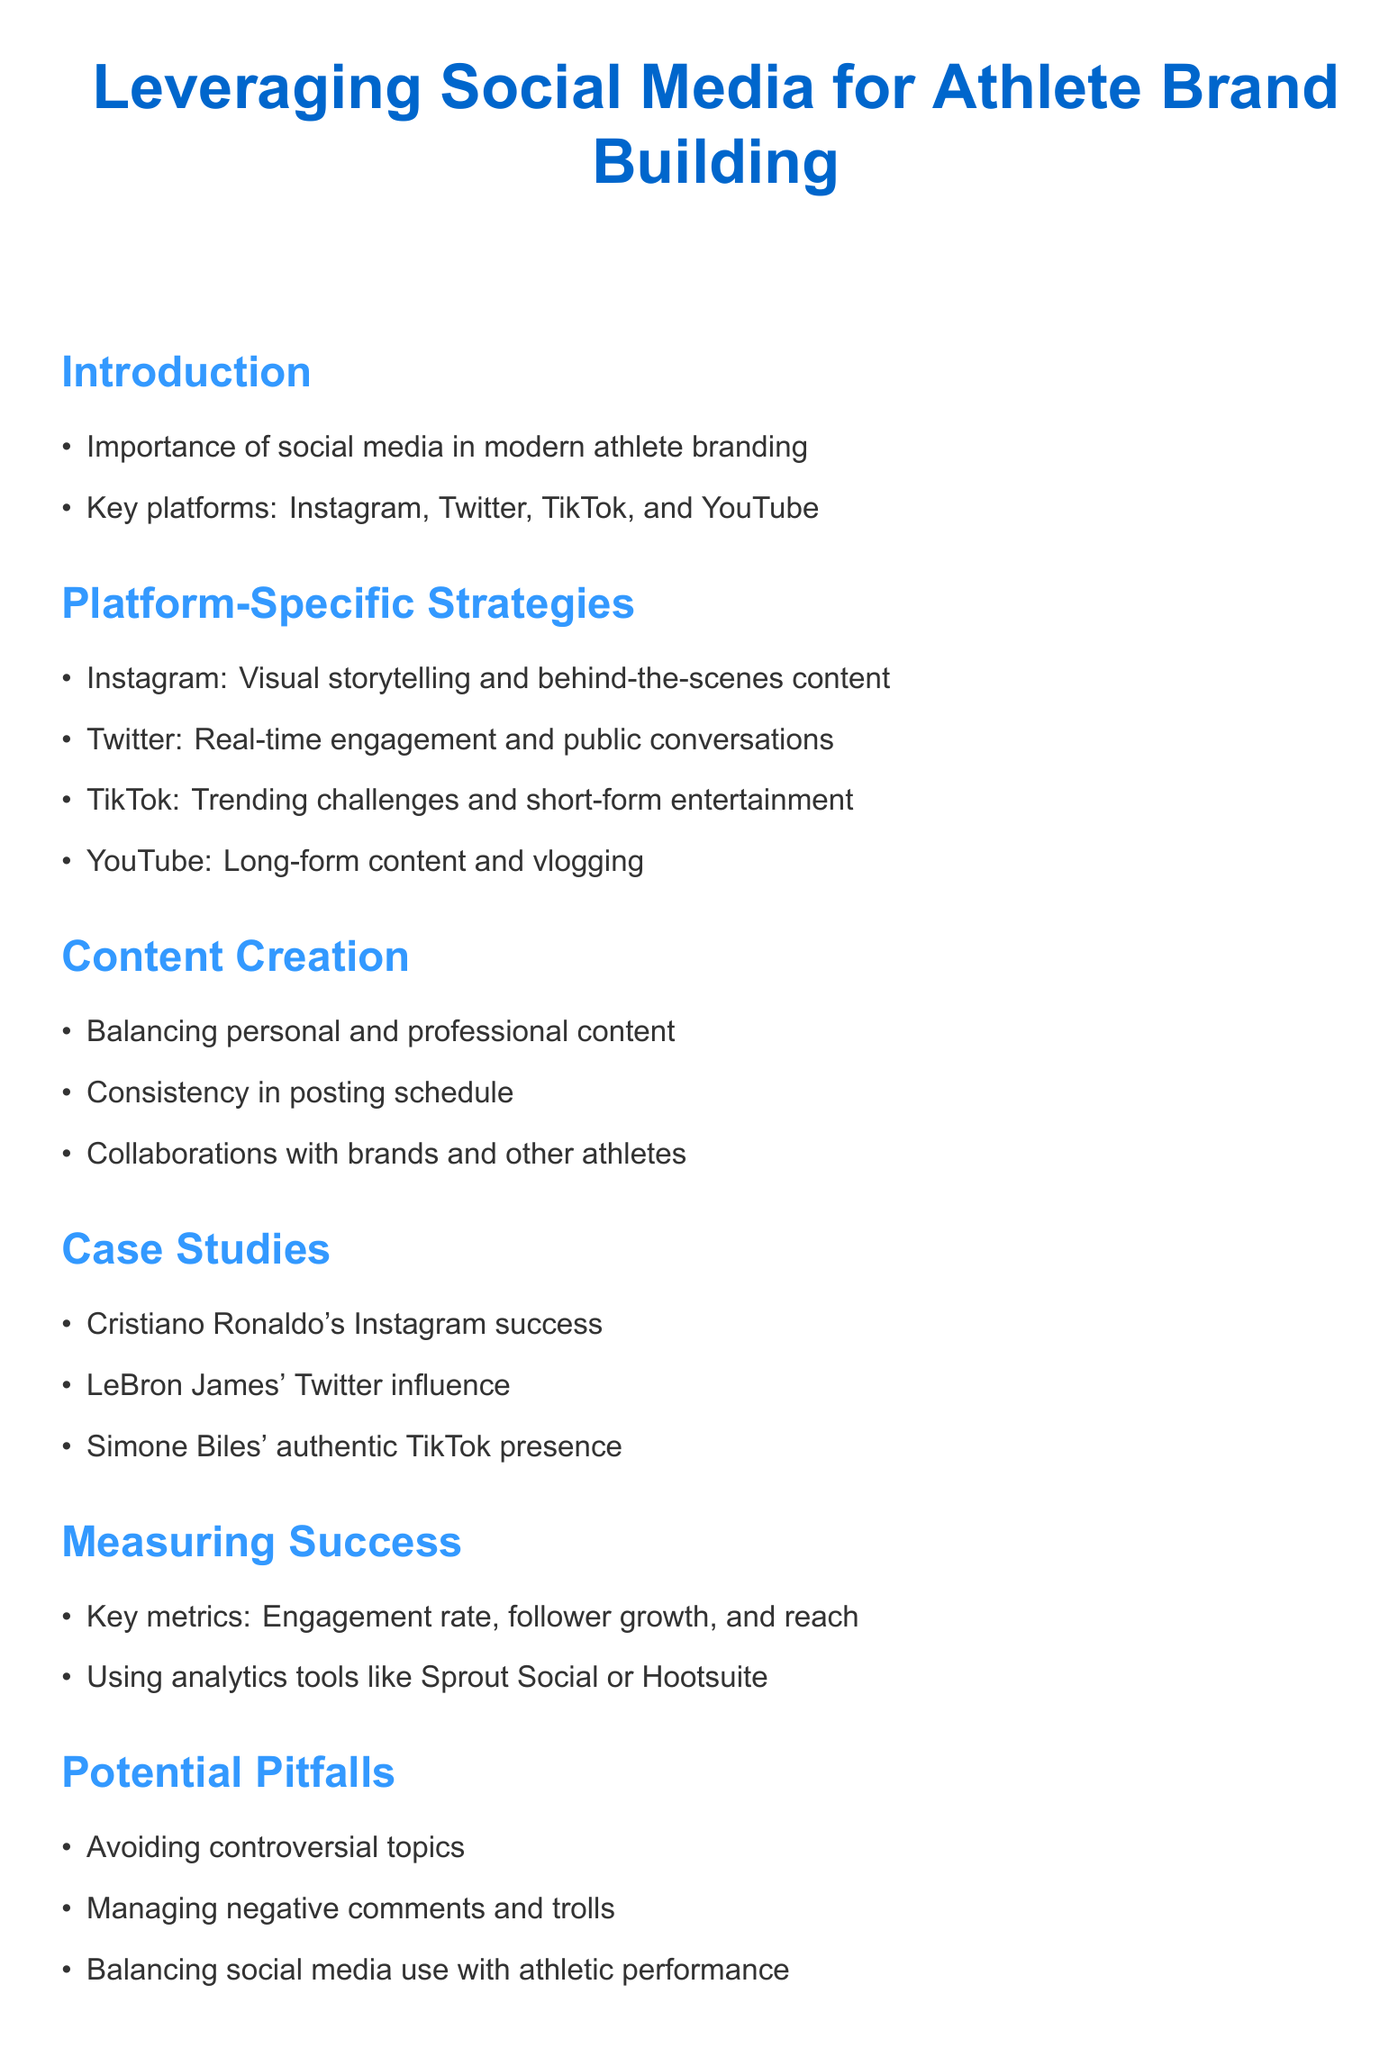What are the key platforms for athlete branding? The document lists Instagram, Twitter, TikTok, and YouTube as key platforms for athlete branding.
Answer: Instagram, Twitter, TikTok, and YouTube What is an example of content strategy for Instagram? The document states that on Instagram, athletes should focus on visual storytelling and behind-the-scenes content.
Answer: Visual storytelling and behind-the-scenes content What should be balanced in content creation? The document mentions the need to balance personal and professional content in athlete's social media.
Answer: Personal and professional content Who has had Instagram success mentioned in the case studies? Cristiano Ronaldo is highlighted in the document as an example of Instagram success.
Answer: Cristiano Ronaldo What are key metrics for measuring success in social media? The document identifies engagement rate, follower growth, and reach as key metrics for success.
Answer: Engagement rate, follower growth, and reach What potential pitfall is mentioned regarding social media use? The document advises to avoid controversial topics as a potential pitfall in social media use.
Answer: Avoiding controversial topics What future technology is discussed for athlete branding? The document mentions NFTs and blockchain technology as a future trend in athlete branding.
Answer: NFTs and blockchain technology What type of content is suggested for TikTok? The document suggests trending challenges and short-form entertainment as suitable content for TikTok.
Answer: Trending challenges and short-form entertainment How is LeBron James' influence characterized? The document characterizes LeBron James' influence as significant on Twitter.
Answer: Twitter influence 